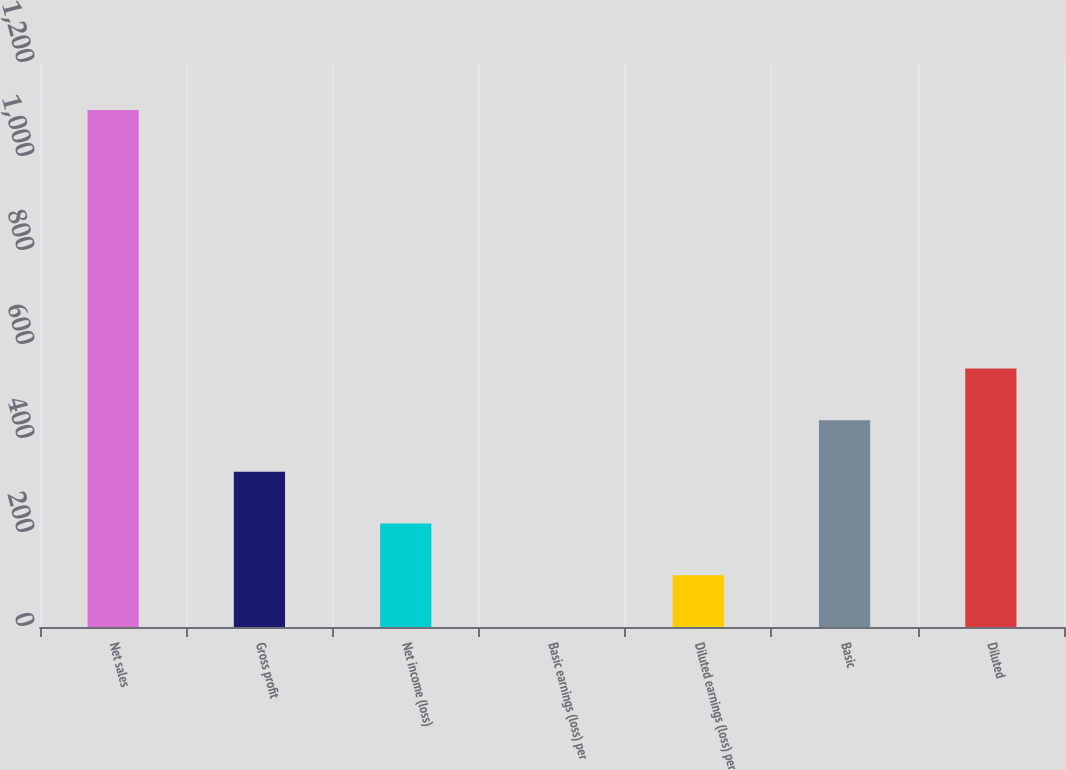Convert chart to OTSL. <chart><loc_0><loc_0><loc_500><loc_500><bar_chart><fcel>Net sales<fcel>Gross profit<fcel>Net income (loss)<fcel>Basic earnings (loss) per<fcel>Diluted earnings (loss) per<fcel>Basic<fcel>Diluted<nl><fcel>1100<fcel>330.08<fcel>220.09<fcel>0.11<fcel>110.1<fcel>440.07<fcel>550.06<nl></chart> 